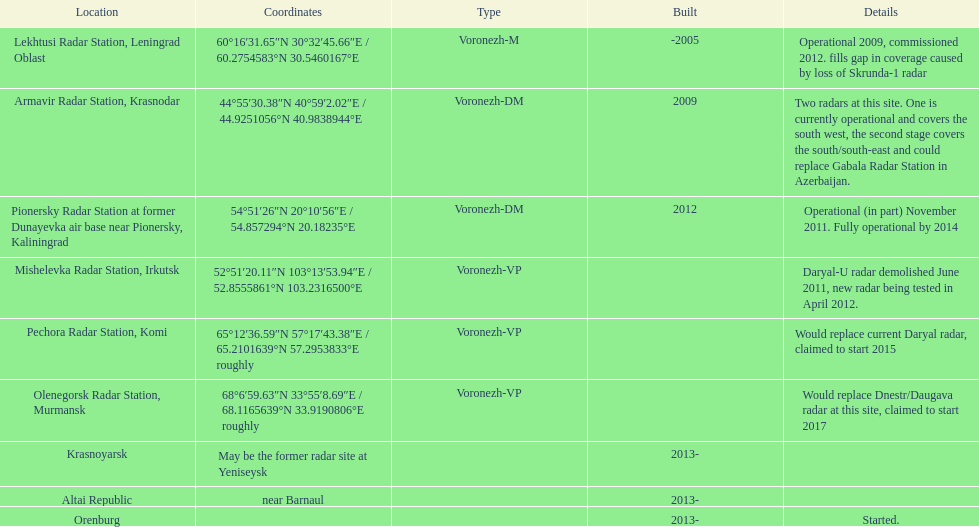What year built is at the top? -2005. 